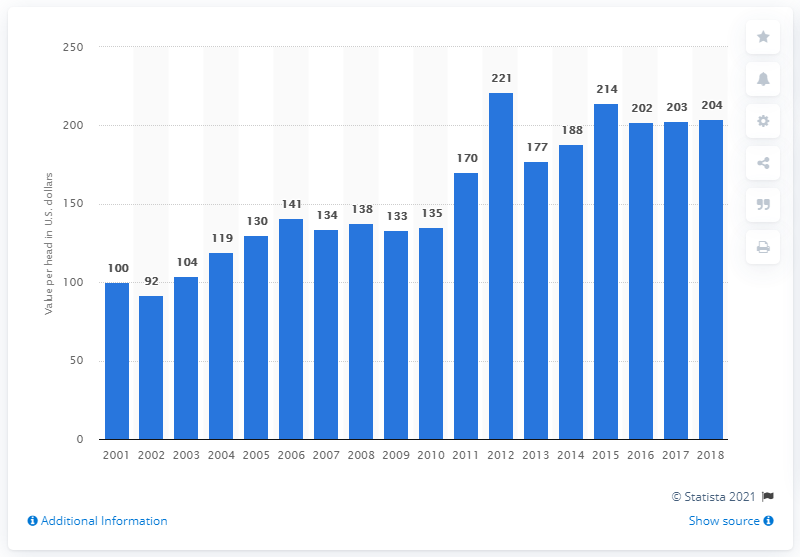Outline some significant characteristics in this image. In 2001, the average value per head of sheep and lambs in the United States was 100. In 2018, the average value per head of sheep and lambs in the United States was $204. 